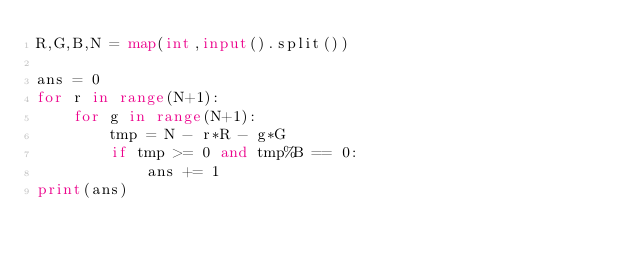<code> <loc_0><loc_0><loc_500><loc_500><_Python_>R,G,B,N = map(int,input().split())

ans = 0
for r in range(N+1):
    for g in range(N+1):
        tmp = N - r*R - g*G
        if tmp >= 0 and tmp%B == 0:
            ans += 1
print(ans)</code> 